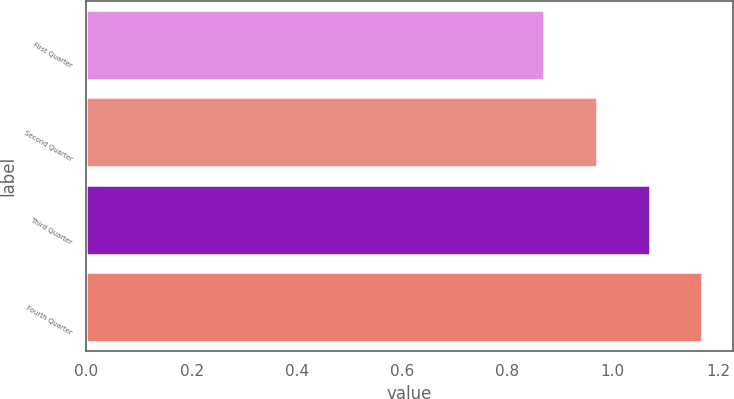<chart> <loc_0><loc_0><loc_500><loc_500><bar_chart><fcel>First Quarter<fcel>Second Quarter<fcel>Third Quarter<fcel>Fourth Quarter<nl><fcel>0.87<fcel>0.97<fcel>1.07<fcel>1.17<nl></chart> 